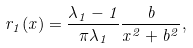<formula> <loc_0><loc_0><loc_500><loc_500>r _ { 1 } ( x ) = \frac { { \lambda } _ { 1 } - 1 } { \pi { \lambda } _ { 1 } } \frac { b } { x ^ { 2 } + b ^ { 2 } } ,</formula> 